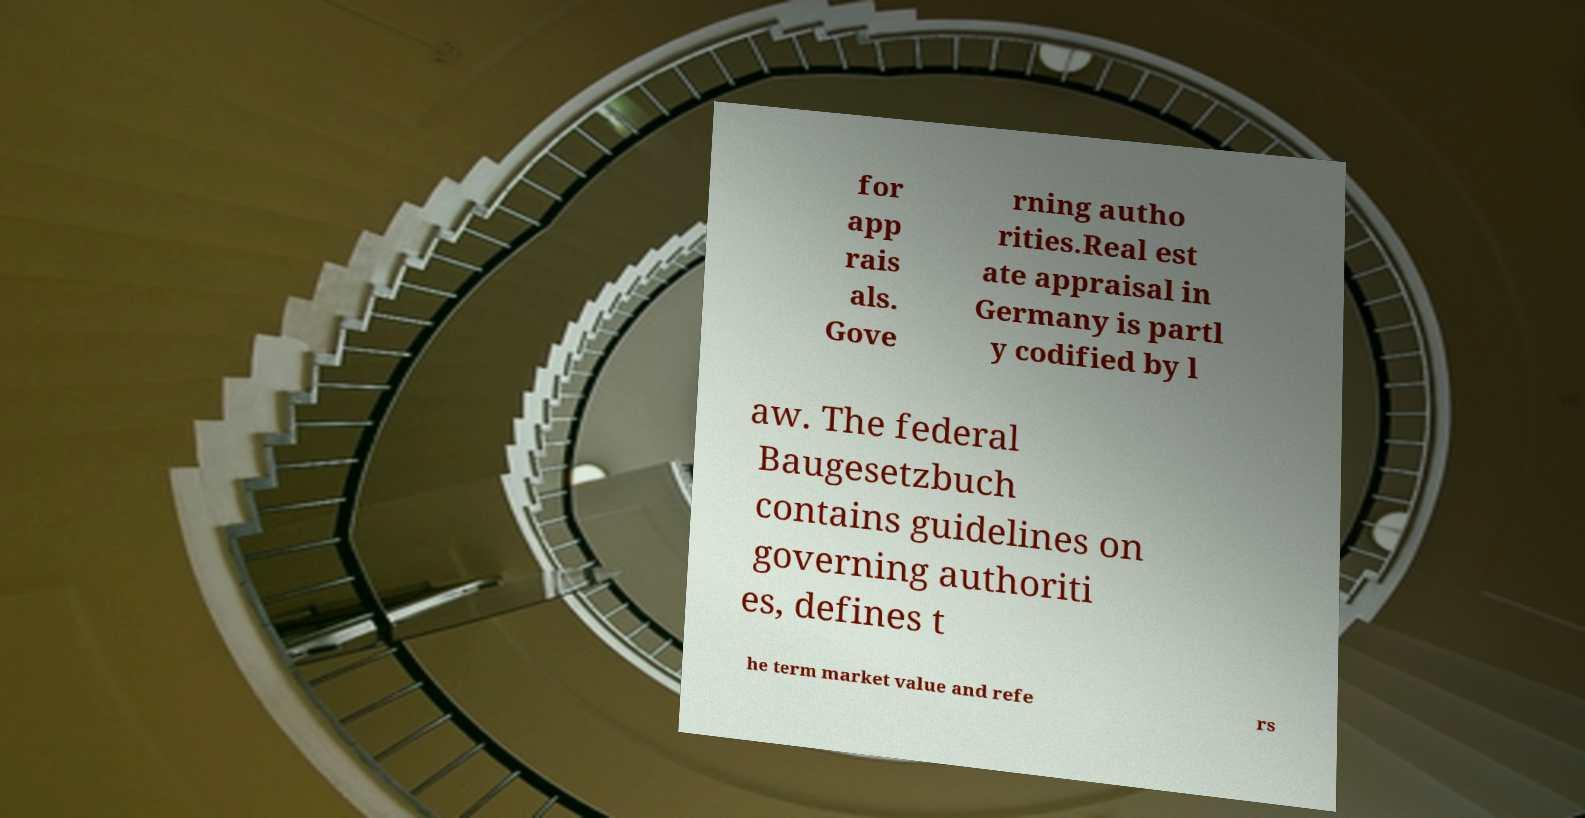Please read and relay the text visible in this image. What does it say? for app rais als. Gove rning autho rities.Real est ate appraisal in Germany is partl y codified by l aw. The federal Baugesetzbuch contains guidelines on governing authoriti es, defines t he term market value and refe rs 